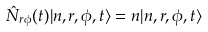Convert formula to latex. <formula><loc_0><loc_0><loc_500><loc_500>\hat { N } _ { r \phi } ( t ) | n , r , \phi , t \rangle = n | n , r , \phi , t \rangle</formula> 